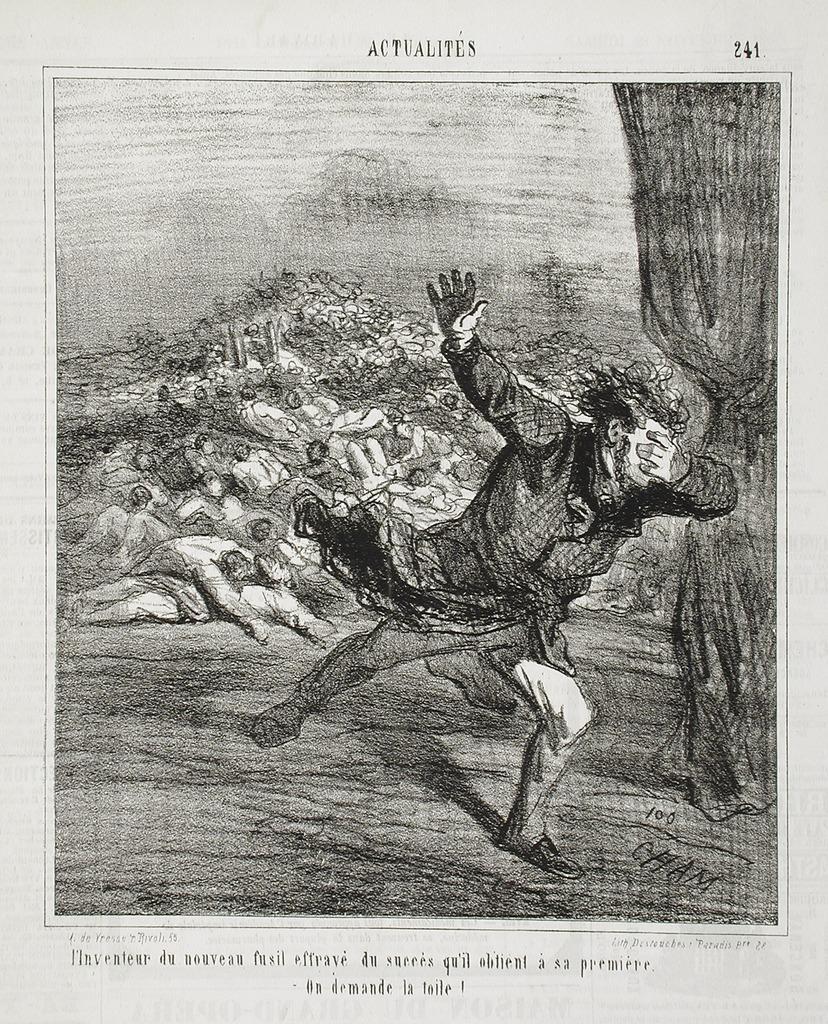How would you summarize this image in a sentence or two? In this picture I can see a printed paper and I can see a picture of a man running and I can see text at the top and the bottom of the picture 